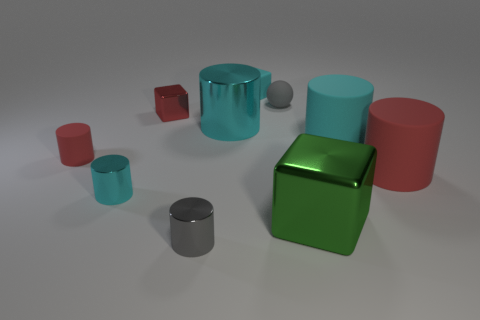Subtract all gray spheres. How many cyan cylinders are left? 3 Subtract all gray cylinders. How many cylinders are left? 5 Subtract all small cyan cylinders. How many cylinders are left? 5 Subtract all yellow cylinders. Subtract all green balls. How many cylinders are left? 6 Subtract all cylinders. How many objects are left? 4 Subtract 1 green blocks. How many objects are left? 9 Subtract all tiny cyan objects. Subtract all small rubber spheres. How many objects are left? 7 Add 4 matte cylinders. How many matte cylinders are left? 7 Add 1 gray matte cubes. How many gray matte cubes exist? 1 